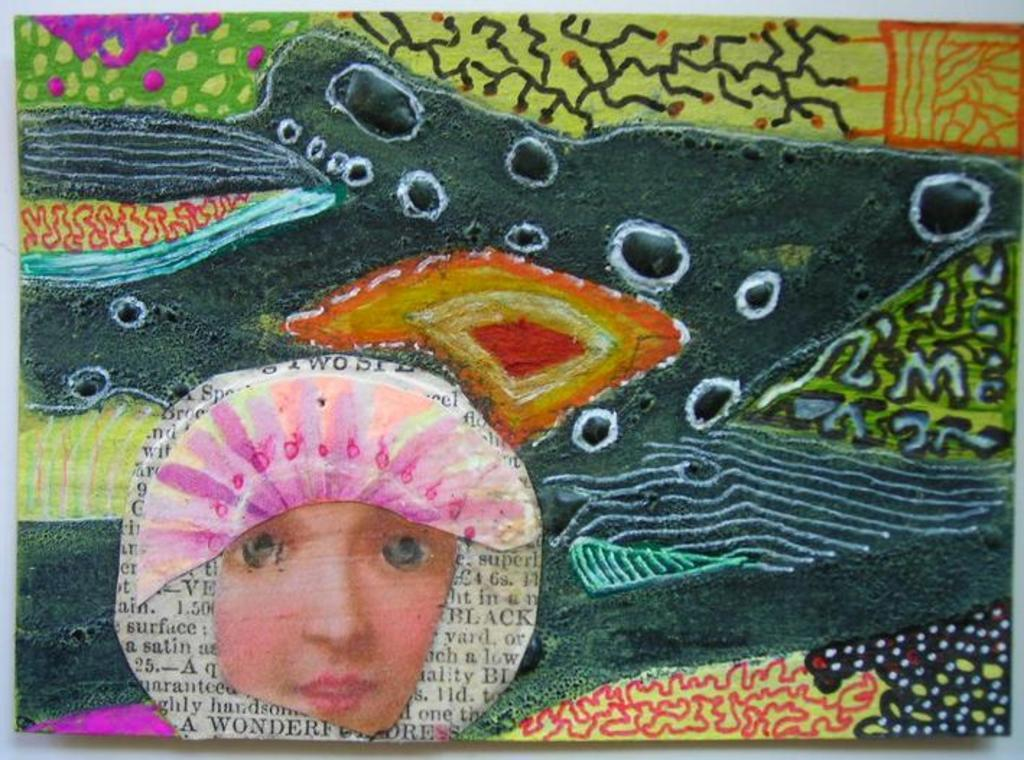What is present on the paper in the image? There is a paper in the image, and it contains text, a painting, and a person's face on the left side. What is the subject of the painting on the paper? The painting on the paper is not described in the facts, so we cannot determine its subject. What is the background of the paper? The background of the paper appears to be a plane. What type of steel is used to create the boat in the image? There is no boat present in the image, so we cannot determine the type of steel used. 